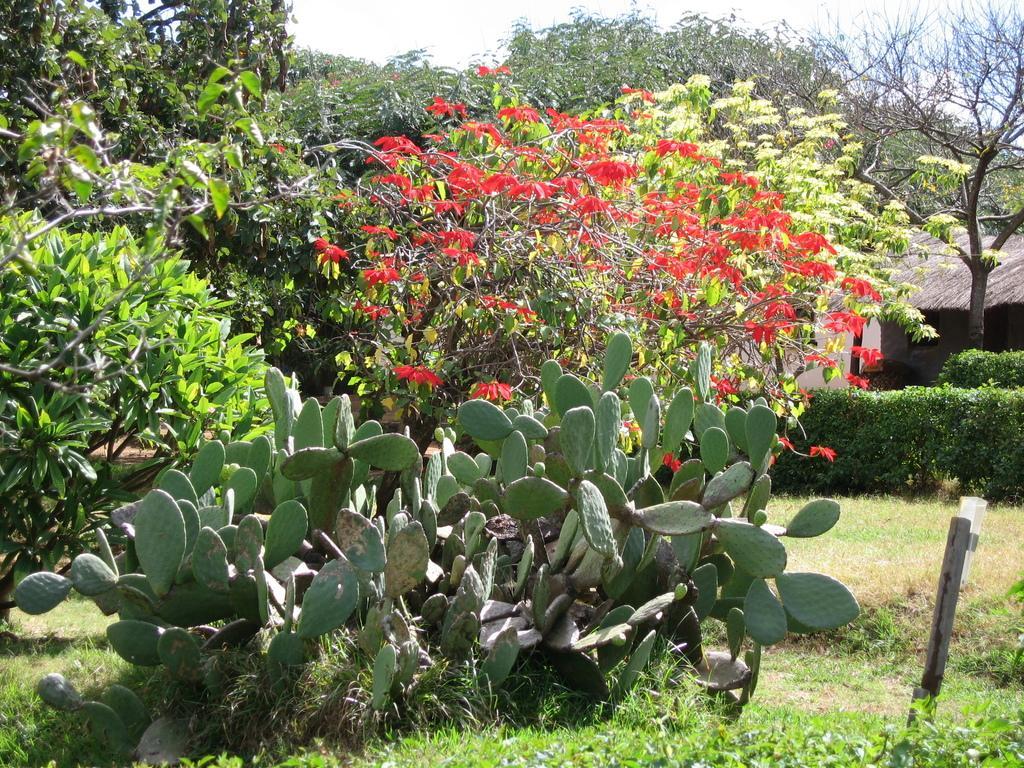How would you summarize this image in a sentence or two? In this image, we can see some trees. There are desert plants at the bottom of the image. There is a sky at the top of the image. 